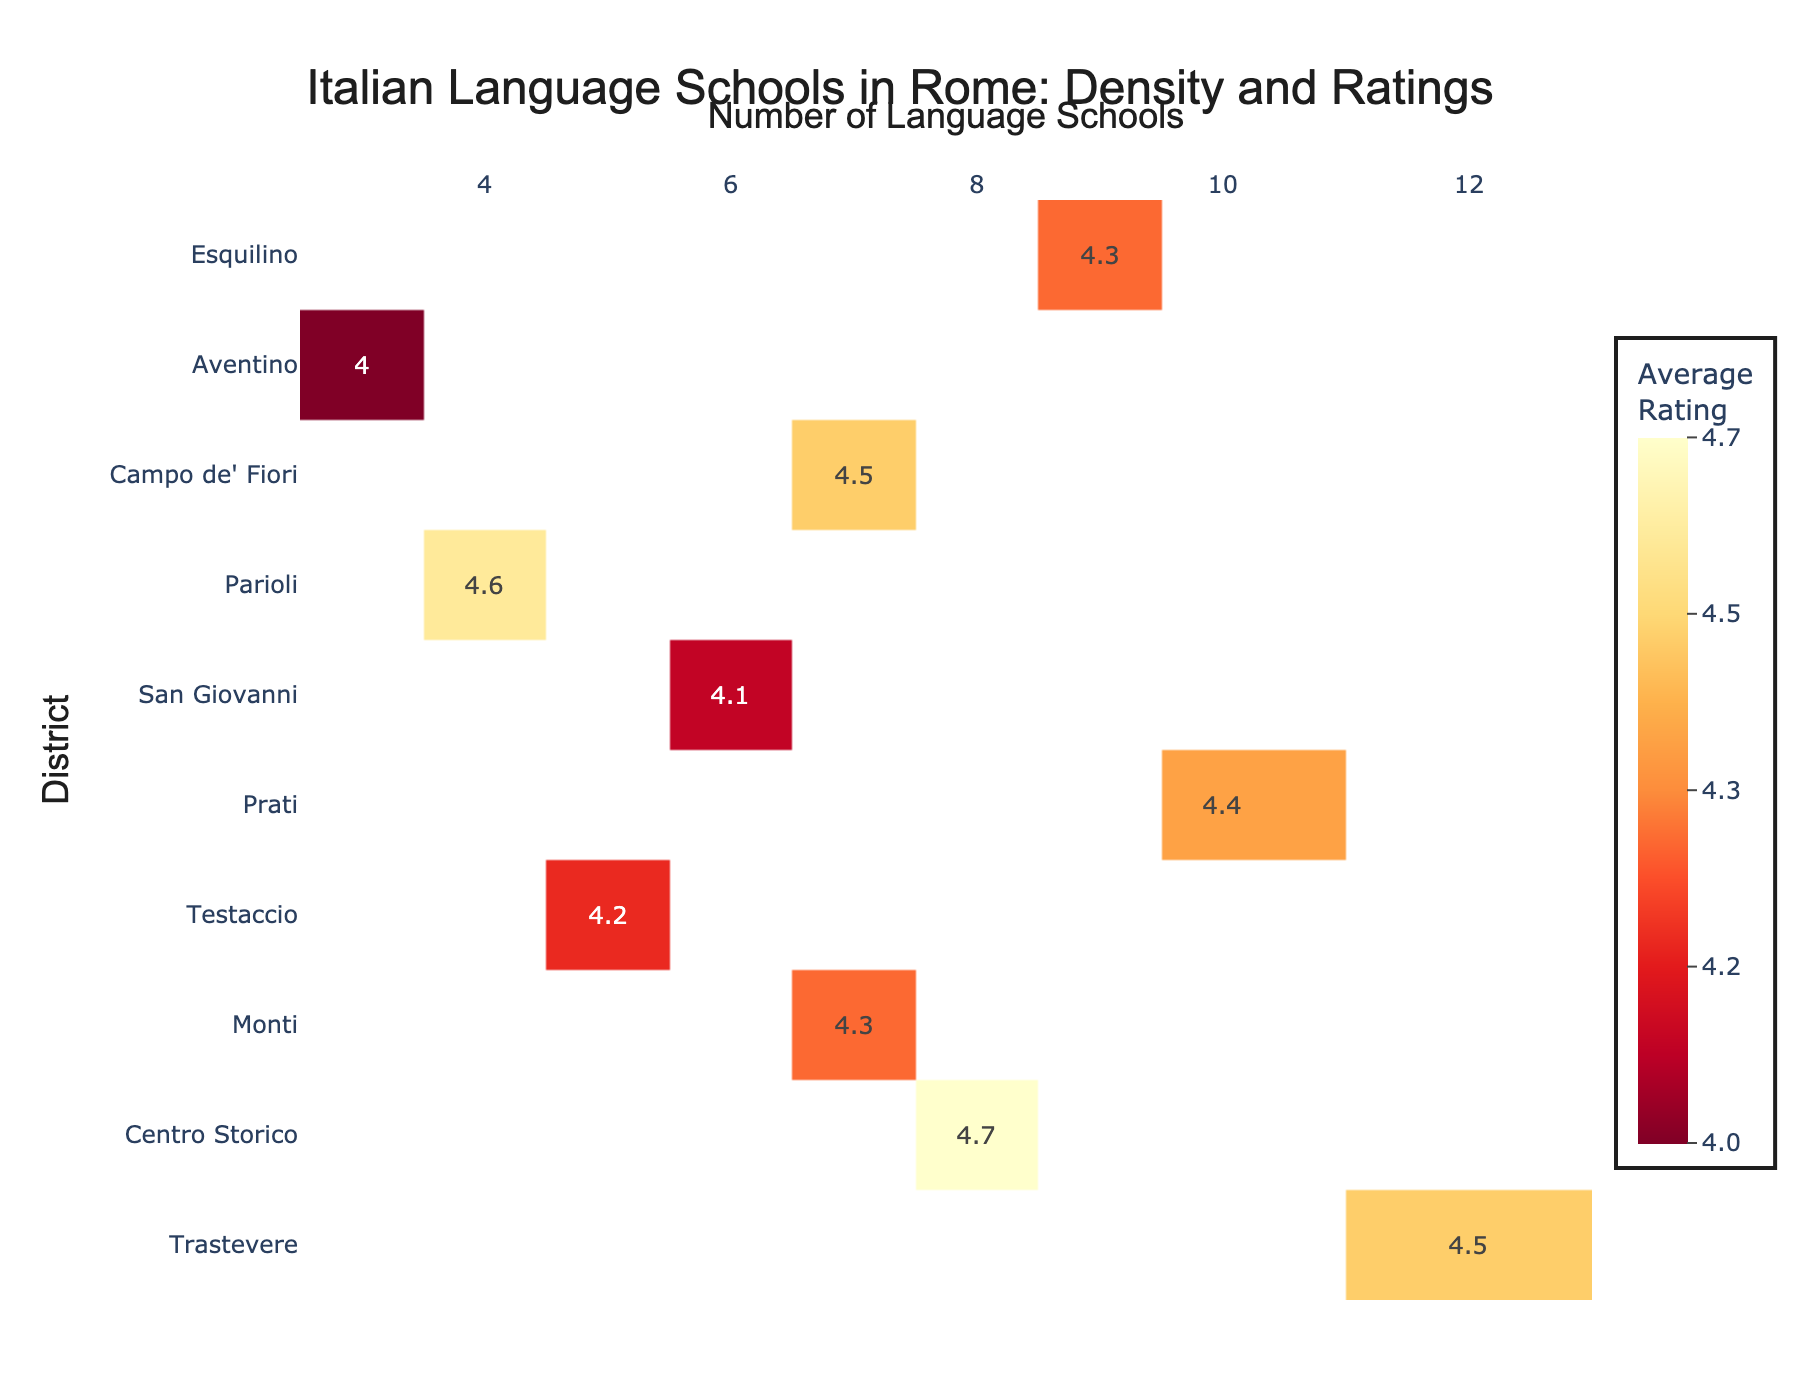what is the title of the plot? The title of the plot is located at the top center of the figure. It reads "Italian Language Schools in Rome: Density and Ratings".
Answer: Italian Language Schools in Rome: Density and Ratings How many language schools are there in Trastevere? Locate the row corresponding to Trastevere on the y-axis and observe the value on the x-axis. The number of language schools in Trastevere is 12.
Answer: 12 Which district has the highest average rating? Scan the heatmap for the highest value on the color scale. The district with an average rating of 4.7 is Centro Storico.
Answer: Centro Storico What is the average rating of language schools in Prati? Find the row labeled Prati and observe the value on the heatmap, which represents the average rating for that district. The average rating in Prati is 4.4.
Answer: 4.4 Which district has the fewest language schools? Find the row with the lowest value on the x-axis. Aventino has the fewest language schools, with a total of 3.
Answer: Aventino How many districts have an average rating of 4.5 or higher? Count the districts with an average rating of 4.5 or higher by examining the heatmap values. Trastevere, Centro Storico, and Campo de' Fiori each have average ratings of 4.5 or higher, making a total of 3 districts.
Answer: 3 What is the combined number of language schools in Centro Storico and Monti? Add the number of language schools in Centro Storico (8) and Monti (7) together. 8 + 7 = 15.
Answer: 15 Compare the average ratings of Monti and Parioli. Which one is higher? Find the average ratings of Monti (4.3) and Parioli (4.6) and compare them. Parioli's average rating is higher.
Answer: Parioli Which district has exactly 9 language schools? Locate the district with a value of 9 on the x-axis. Esquilino has exactly 9 language schools.
Answer: Esquilino Between Testaccio and San Giovanni, which district has a lower average rating and what is it? Compare the average ratings of Testaccio (4.2) and San Giovanni (4.1). San Giovanni has the lower average rating of 4.1.
Answer: San Giovanni, 4.1 